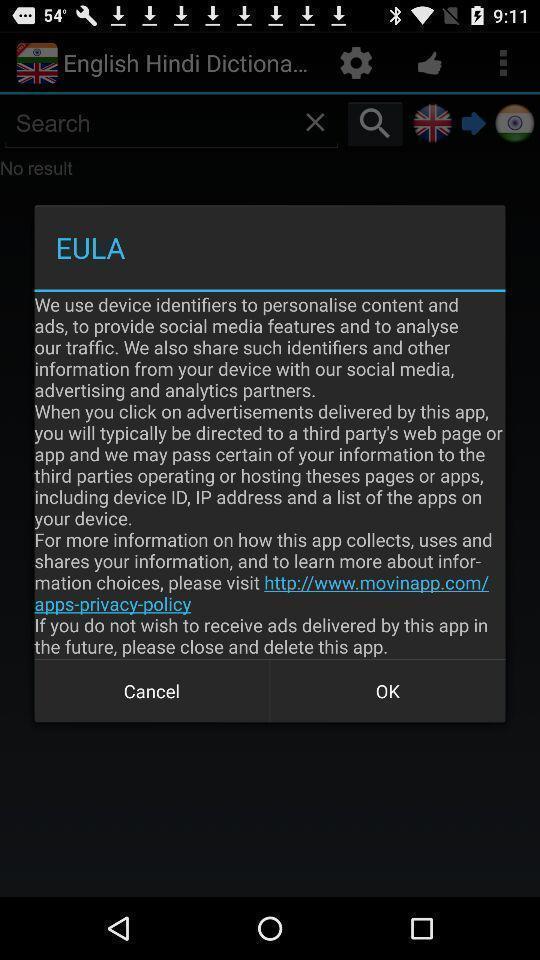Tell me about the visual elements in this screen capture. Pop-up displays device information in app. 